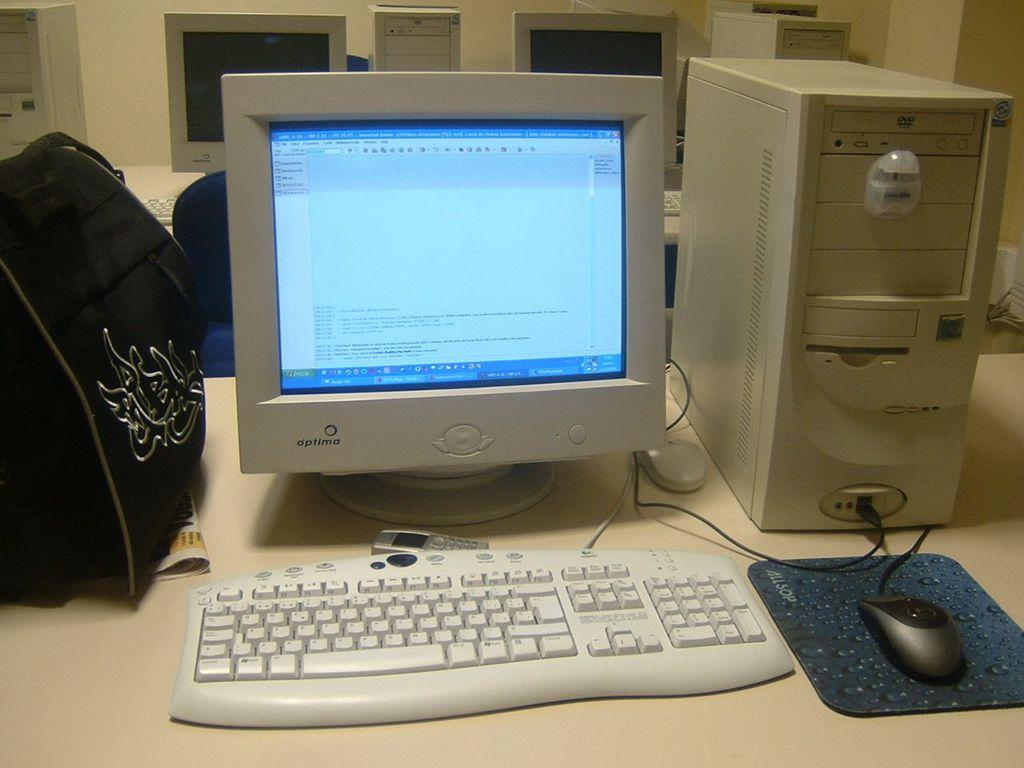Provide a one-sentence caption for the provided image. A desktop computer running a word processing program. 